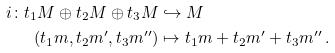Convert formula to latex. <formula><loc_0><loc_0><loc_500><loc_500>i \colon t _ { 1 } M \oplus t _ { 2 } M \oplus t _ { 3 } M & \hookrightarrow M \\ ( t _ { 1 } m , t _ { 2 } m ^ { \prime } , t _ { 3 } m ^ { \prime \prime } ) & \mapsto t _ { 1 } m + t _ { 2 } m ^ { \prime } + t _ { 3 } m ^ { \prime \prime } \, .</formula> 